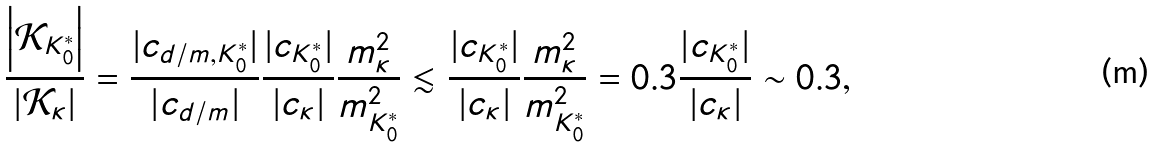<formula> <loc_0><loc_0><loc_500><loc_500>\frac { \left | \mathcal { K } _ { K _ { 0 } ^ { * } } \right | } { \left | \mathcal { K } _ { \kappa } \right | } = \frac { | c _ { d / m , K _ { 0 } ^ { * } } | } { | c _ { d / m } | } \frac { | c _ { K _ { 0 } ^ { * } } | } { | c _ { \kappa } | } \frac { m _ { \kappa } ^ { 2 } } { m _ { K _ { 0 } ^ { * } } ^ { 2 } } \lesssim \frac { | c _ { K _ { 0 } ^ { * } } | } { | c _ { \kappa } | } \frac { m _ { \kappa } ^ { 2 } } { m _ { K _ { 0 } ^ { * } } ^ { 2 } } = 0 . 3 \frac { | c _ { K _ { 0 } ^ { * } } | } { | c _ { \kappa } | } \sim 0 . 3 ,</formula> 